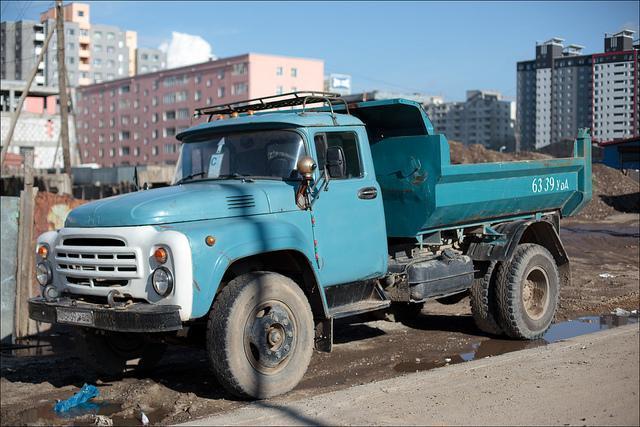How many trucks?
Give a very brief answer. 1. How many wheels are on the truck?
Give a very brief answer. 6. How many wheels does the truck have?
Give a very brief answer. 6. How many trucks can you see?
Give a very brief answer. 1. 